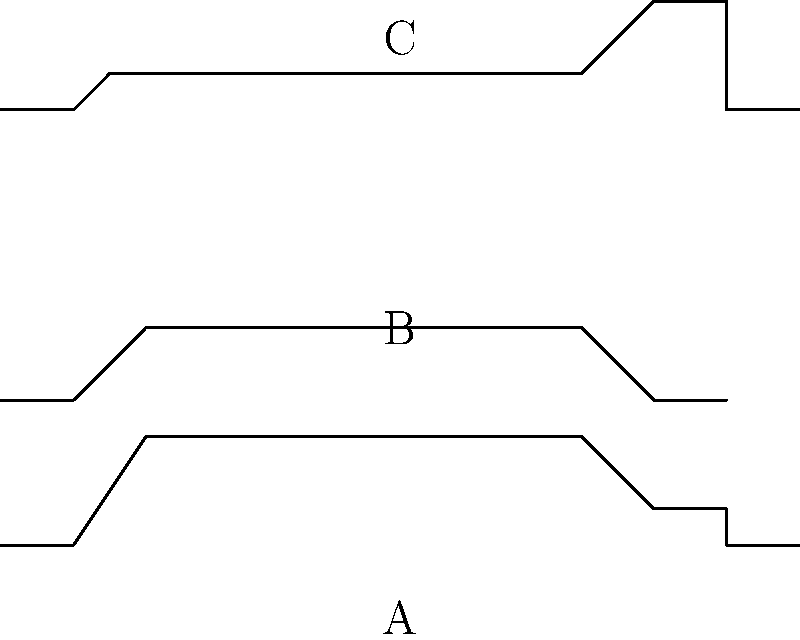Identify the classic American muscle cars represented by the silhouettes A, B, and C. Which one is the Dodge Charger? To identify the Dodge Charger among the given silhouettes, let's analyze each one:

1. Silhouette A (top):
   - Long hood
   - Distinctive "fastback" roofline
   - Slight dip in the rear quarter panel
   This silhouette represents the Ford Mustang.

2. Silhouette B (middle):
   - Shorter hood compared to A
   - More rounded roofline
   - Distinctive rear quarter panel shape
   This silhouette represents the Chevrolet Camaro.

3. Silhouette C (bottom):
   - Long, flat hood
   - Distinctive "Coke bottle" shape in the body
   - Unique rear roof pillar design (flying buttress)
   This silhouette matches the characteristics of the Dodge Charger.

The Dodge Charger is known for its long, flat hood and distinctive "Coke bottle" shape, which is clearly visible in silhouette C. The unique rear roof pillar design, often called the "flying buttress," is a defining feature of the Charger, especially in its second-generation models (1968-1970).
Answer: C 